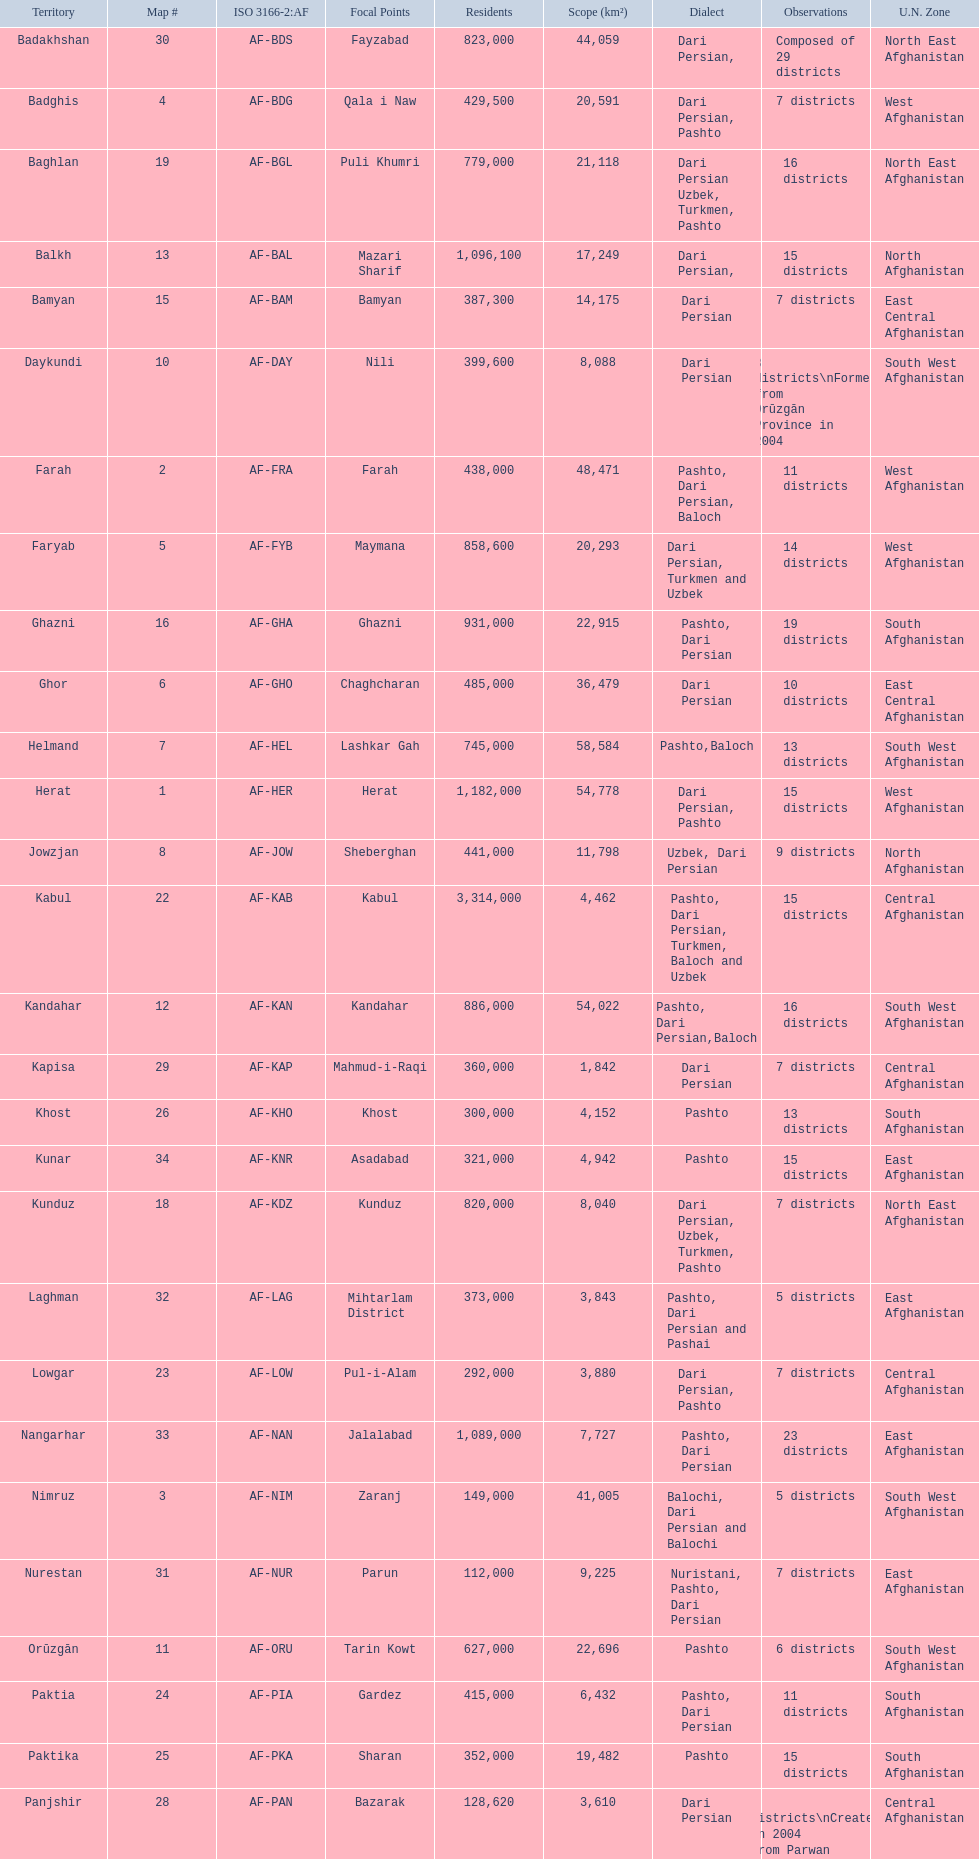How many districts are in the province of kunduz? 7. 